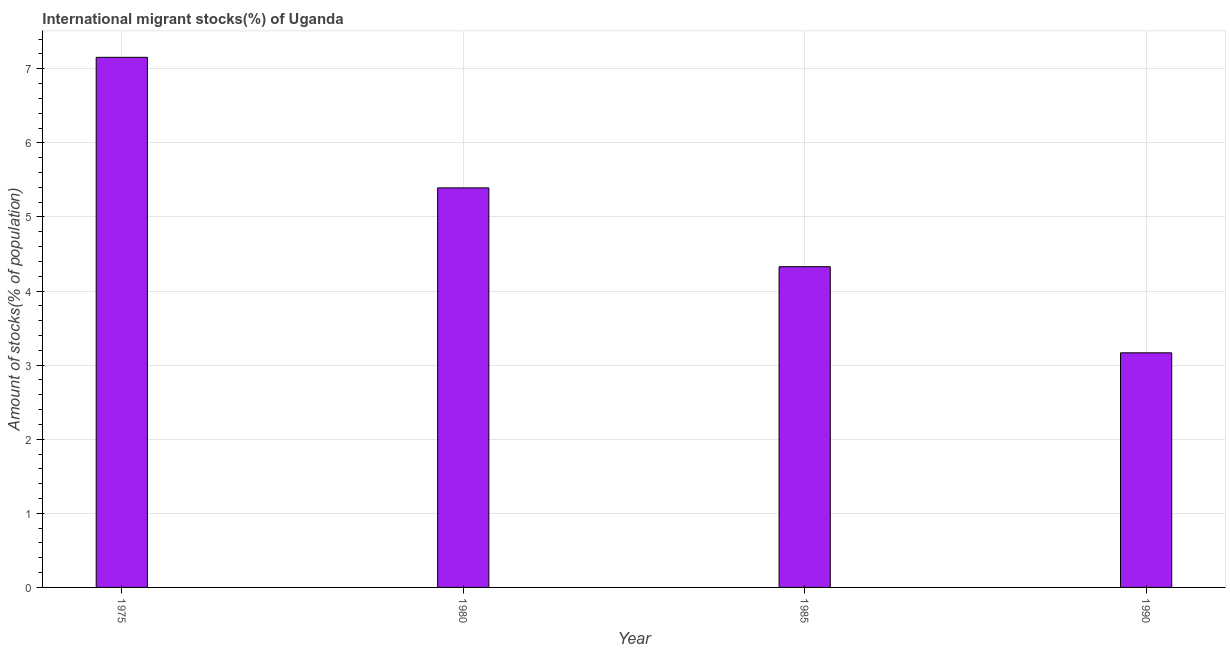Does the graph contain grids?
Ensure brevity in your answer.  Yes. What is the title of the graph?
Your answer should be compact. International migrant stocks(%) of Uganda. What is the label or title of the Y-axis?
Your answer should be very brief. Amount of stocks(% of population). What is the number of international migrant stocks in 1980?
Ensure brevity in your answer.  5.39. Across all years, what is the maximum number of international migrant stocks?
Your answer should be compact. 7.15. Across all years, what is the minimum number of international migrant stocks?
Provide a short and direct response. 3.17. In which year was the number of international migrant stocks maximum?
Your answer should be compact. 1975. In which year was the number of international migrant stocks minimum?
Make the answer very short. 1990. What is the sum of the number of international migrant stocks?
Provide a short and direct response. 20.04. What is the difference between the number of international migrant stocks in 1980 and 1990?
Give a very brief answer. 2.23. What is the average number of international migrant stocks per year?
Offer a terse response. 5.01. What is the median number of international migrant stocks?
Provide a succinct answer. 4.86. What is the ratio of the number of international migrant stocks in 1980 to that in 1985?
Your answer should be compact. 1.25. Is the number of international migrant stocks in 1975 less than that in 1990?
Provide a short and direct response. No. Is the difference between the number of international migrant stocks in 1985 and 1990 greater than the difference between any two years?
Provide a succinct answer. No. What is the difference between the highest and the second highest number of international migrant stocks?
Ensure brevity in your answer.  1.76. Is the sum of the number of international migrant stocks in 1985 and 1990 greater than the maximum number of international migrant stocks across all years?
Provide a succinct answer. Yes. What is the difference between the highest and the lowest number of international migrant stocks?
Offer a very short reply. 3.99. In how many years, is the number of international migrant stocks greater than the average number of international migrant stocks taken over all years?
Provide a succinct answer. 2. How many bars are there?
Your answer should be compact. 4. How many years are there in the graph?
Your response must be concise. 4. What is the difference between two consecutive major ticks on the Y-axis?
Offer a terse response. 1. Are the values on the major ticks of Y-axis written in scientific E-notation?
Provide a short and direct response. No. What is the Amount of stocks(% of population) of 1975?
Offer a terse response. 7.15. What is the Amount of stocks(% of population) in 1980?
Keep it short and to the point. 5.39. What is the Amount of stocks(% of population) in 1985?
Your response must be concise. 4.33. What is the Amount of stocks(% of population) of 1990?
Your answer should be compact. 3.17. What is the difference between the Amount of stocks(% of population) in 1975 and 1980?
Provide a succinct answer. 1.76. What is the difference between the Amount of stocks(% of population) in 1975 and 1985?
Provide a succinct answer. 2.83. What is the difference between the Amount of stocks(% of population) in 1975 and 1990?
Give a very brief answer. 3.99. What is the difference between the Amount of stocks(% of population) in 1980 and 1985?
Offer a terse response. 1.06. What is the difference between the Amount of stocks(% of population) in 1980 and 1990?
Offer a terse response. 2.23. What is the difference between the Amount of stocks(% of population) in 1985 and 1990?
Ensure brevity in your answer.  1.16. What is the ratio of the Amount of stocks(% of population) in 1975 to that in 1980?
Give a very brief answer. 1.33. What is the ratio of the Amount of stocks(% of population) in 1975 to that in 1985?
Ensure brevity in your answer.  1.65. What is the ratio of the Amount of stocks(% of population) in 1975 to that in 1990?
Make the answer very short. 2.26. What is the ratio of the Amount of stocks(% of population) in 1980 to that in 1985?
Give a very brief answer. 1.25. What is the ratio of the Amount of stocks(% of population) in 1980 to that in 1990?
Ensure brevity in your answer.  1.7. What is the ratio of the Amount of stocks(% of population) in 1985 to that in 1990?
Your response must be concise. 1.37. 